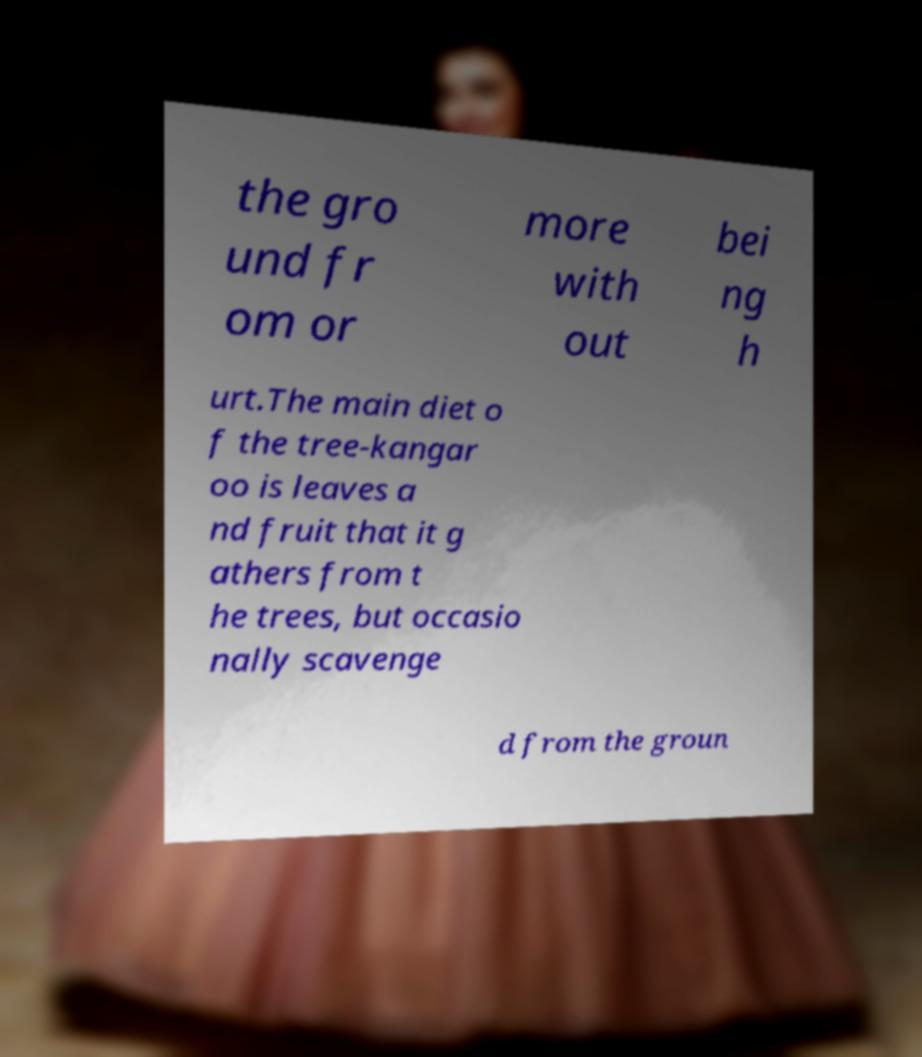What messages or text are displayed in this image? I need them in a readable, typed format. the gro und fr om or more with out bei ng h urt.The main diet o f the tree-kangar oo is leaves a nd fruit that it g athers from t he trees, but occasio nally scavenge d from the groun 